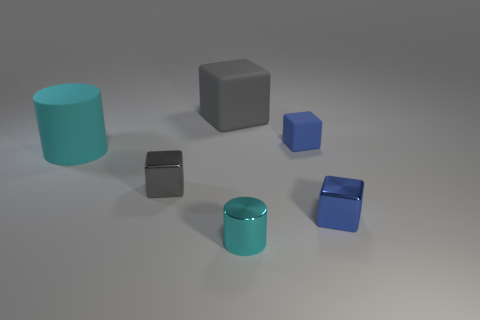What is the material of the small cyan thing? The small cyan object appears to be made of a glossy material, which could be either metal or plastic, as it reflects light and has a smooth surface. 